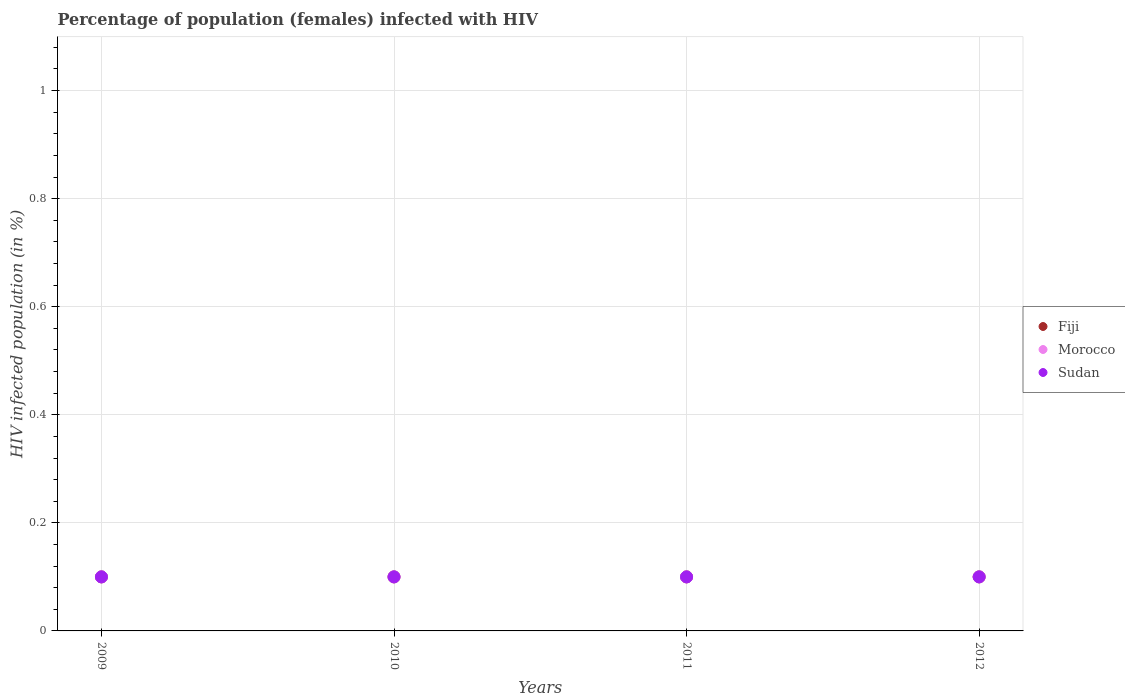What is the percentage of HIV infected female population in Morocco in 2010?
Your answer should be very brief. 0.1. Across all years, what is the minimum percentage of HIV infected female population in Fiji?
Make the answer very short. 0.1. In which year was the percentage of HIV infected female population in Sudan maximum?
Ensure brevity in your answer.  2009. What is the total percentage of HIV infected female population in Sudan in the graph?
Make the answer very short. 0.4. What is the difference between the percentage of HIV infected female population in Fiji in 2011 and the percentage of HIV infected female population in Sudan in 2012?
Your answer should be very brief. 0. What is the average percentage of HIV infected female population in Morocco per year?
Give a very brief answer. 0.1. In the year 2009, what is the difference between the percentage of HIV infected female population in Sudan and percentage of HIV infected female population in Morocco?
Offer a terse response. 0. Is the percentage of HIV infected female population in Sudan in 2009 less than that in 2011?
Give a very brief answer. No. What is the difference between the highest and the second highest percentage of HIV infected female population in Fiji?
Your response must be concise. 0. What is the difference between the highest and the lowest percentage of HIV infected female population in Morocco?
Your response must be concise. 0. Is the sum of the percentage of HIV infected female population in Fiji in 2009 and 2011 greater than the maximum percentage of HIV infected female population in Sudan across all years?
Provide a short and direct response. Yes. Is it the case that in every year, the sum of the percentage of HIV infected female population in Sudan and percentage of HIV infected female population in Fiji  is greater than the percentage of HIV infected female population in Morocco?
Your answer should be compact. Yes. Does the percentage of HIV infected female population in Sudan monotonically increase over the years?
Make the answer very short. No. Is the percentage of HIV infected female population in Sudan strictly greater than the percentage of HIV infected female population in Fiji over the years?
Offer a very short reply. No. Is the percentage of HIV infected female population in Sudan strictly less than the percentage of HIV infected female population in Fiji over the years?
Keep it short and to the point. No. How many dotlines are there?
Offer a terse response. 3. Does the graph contain any zero values?
Offer a terse response. No. Does the graph contain grids?
Your answer should be very brief. Yes. Where does the legend appear in the graph?
Ensure brevity in your answer.  Center right. How are the legend labels stacked?
Your answer should be very brief. Vertical. What is the title of the graph?
Provide a succinct answer. Percentage of population (females) infected with HIV. Does "Mongolia" appear as one of the legend labels in the graph?
Make the answer very short. No. What is the label or title of the Y-axis?
Provide a short and direct response. HIV infected population (in %). What is the HIV infected population (in %) in Fiji in 2009?
Your answer should be compact. 0.1. What is the HIV infected population (in %) in Morocco in 2010?
Your response must be concise. 0.1. What is the HIV infected population (in %) of Sudan in 2010?
Offer a very short reply. 0.1. What is the HIV infected population (in %) of Fiji in 2011?
Provide a succinct answer. 0.1. What is the HIV infected population (in %) of Sudan in 2011?
Provide a short and direct response. 0.1. Across all years, what is the maximum HIV infected population (in %) in Morocco?
Your response must be concise. 0.1. Across all years, what is the minimum HIV infected population (in %) in Morocco?
Provide a short and direct response. 0.1. What is the total HIV infected population (in %) in Fiji in the graph?
Make the answer very short. 0.4. What is the difference between the HIV infected population (in %) in Fiji in 2009 and that in 2010?
Make the answer very short. 0. What is the difference between the HIV infected population (in %) in Morocco in 2009 and that in 2010?
Offer a terse response. 0. What is the difference between the HIV infected population (in %) of Fiji in 2009 and that in 2011?
Ensure brevity in your answer.  0. What is the difference between the HIV infected population (in %) in Morocco in 2009 and that in 2011?
Provide a succinct answer. 0. What is the difference between the HIV infected population (in %) of Fiji in 2009 and that in 2012?
Provide a short and direct response. 0. What is the difference between the HIV infected population (in %) of Morocco in 2009 and that in 2012?
Provide a short and direct response. 0. What is the difference between the HIV infected population (in %) of Sudan in 2009 and that in 2012?
Offer a very short reply. 0. What is the difference between the HIV infected population (in %) of Fiji in 2010 and that in 2012?
Give a very brief answer. 0. What is the difference between the HIV infected population (in %) of Morocco in 2010 and that in 2012?
Ensure brevity in your answer.  0. What is the difference between the HIV infected population (in %) of Fiji in 2011 and that in 2012?
Offer a very short reply. 0. What is the difference between the HIV infected population (in %) in Sudan in 2011 and that in 2012?
Your response must be concise. 0. What is the difference between the HIV infected population (in %) of Fiji in 2009 and the HIV infected population (in %) of Sudan in 2010?
Provide a succinct answer. 0. What is the difference between the HIV infected population (in %) in Fiji in 2009 and the HIV infected population (in %) in Morocco in 2012?
Give a very brief answer. 0. What is the difference between the HIV infected population (in %) of Morocco in 2009 and the HIV infected population (in %) of Sudan in 2012?
Give a very brief answer. 0. What is the difference between the HIV infected population (in %) in Fiji in 2010 and the HIV infected population (in %) in Morocco in 2011?
Your answer should be compact. 0. What is the difference between the HIV infected population (in %) of Fiji in 2010 and the HIV infected population (in %) of Sudan in 2011?
Make the answer very short. 0. What is the difference between the HIV infected population (in %) of Fiji in 2010 and the HIV infected population (in %) of Morocco in 2012?
Keep it short and to the point. 0. What is the difference between the HIV infected population (in %) of Morocco in 2010 and the HIV infected population (in %) of Sudan in 2012?
Ensure brevity in your answer.  0. What is the difference between the HIV infected population (in %) in Fiji in 2011 and the HIV infected population (in %) in Morocco in 2012?
Your response must be concise. 0. What is the difference between the HIV infected population (in %) in Morocco in 2011 and the HIV infected population (in %) in Sudan in 2012?
Keep it short and to the point. 0. In the year 2010, what is the difference between the HIV infected population (in %) in Morocco and HIV infected population (in %) in Sudan?
Your answer should be very brief. 0. In the year 2011, what is the difference between the HIV infected population (in %) of Fiji and HIV infected population (in %) of Morocco?
Ensure brevity in your answer.  0. In the year 2012, what is the difference between the HIV infected population (in %) in Fiji and HIV infected population (in %) in Morocco?
Ensure brevity in your answer.  0. In the year 2012, what is the difference between the HIV infected population (in %) in Fiji and HIV infected population (in %) in Sudan?
Give a very brief answer. 0. What is the ratio of the HIV infected population (in %) in Fiji in 2009 to that in 2010?
Offer a very short reply. 1. What is the ratio of the HIV infected population (in %) in Sudan in 2009 to that in 2010?
Your response must be concise. 1. What is the ratio of the HIV infected population (in %) of Fiji in 2009 to that in 2011?
Keep it short and to the point. 1. What is the ratio of the HIV infected population (in %) of Fiji in 2009 to that in 2012?
Your response must be concise. 1. What is the ratio of the HIV infected population (in %) in Fiji in 2010 to that in 2011?
Your answer should be compact. 1. What is the ratio of the HIV infected population (in %) of Sudan in 2010 to that in 2011?
Provide a short and direct response. 1. What is the ratio of the HIV infected population (in %) in Morocco in 2010 to that in 2012?
Provide a succinct answer. 1. What is the ratio of the HIV infected population (in %) of Sudan in 2010 to that in 2012?
Ensure brevity in your answer.  1. What is the ratio of the HIV infected population (in %) in Morocco in 2011 to that in 2012?
Provide a succinct answer. 1. What is the ratio of the HIV infected population (in %) of Sudan in 2011 to that in 2012?
Your answer should be very brief. 1. What is the difference between the highest and the lowest HIV infected population (in %) in Morocco?
Offer a very short reply. 0. What is the difference between the highest and the lowest HIV infected population (in %) of Sudan?
Provide a succinct answer. 0. 